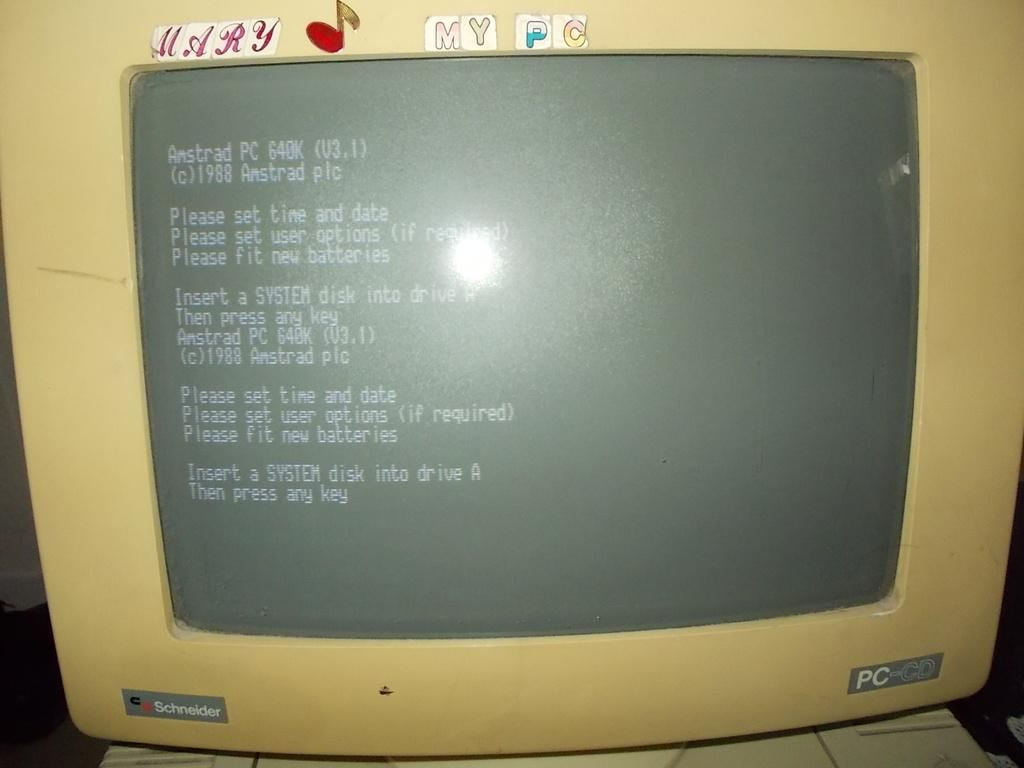<image>
Offer a succinct explanation of the picture presented. An older model Schneider personal computer screen with stickers on it. 